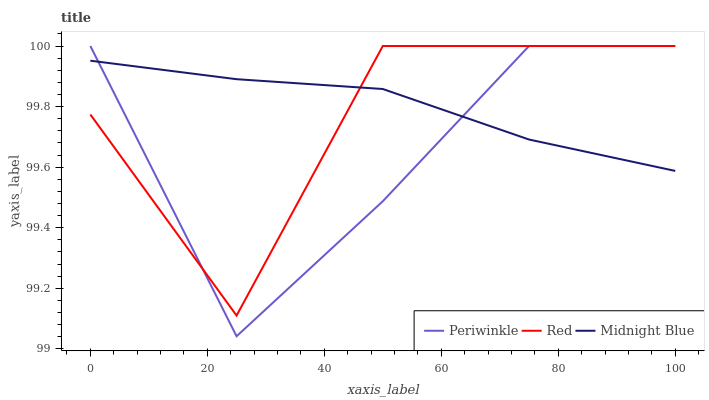Does Periwinkle have the minimum area under the curve?
Answer yes or no. Yes. Does Midnight Blue have the maximum area under the curve?
Answer yes or no. Yes. Does Red have the minimum area under the curve?
Answer yes or no. No. Does Red have the maximum area under the curve?
Answer yes or no. No. Is Midnight Blue the smoothest?
Answer yes or no. Yes. Is Red the roughest?
Answer yes or no. Yes. Is Red the smoothest?
Answer yes or no. No. Is Midnight Blue the roughest?
Answer yes or no. No. Does Periwinkle have the lowest value?
Answer yes or no. Yes. Does Red have the lowest value?
Answer yes or no. No. Does Red have the highest value?
Answer yes or no. Yes. Does Midnight Blue have the highest value?
Answer yes or no. No. Does Red intersect Periwinkle?
Answer yes or no. Yes. Is Red less than Periwinkle?
Answer yes or no. No. Is Red greater than Periwinkle?
Answer yes or no. No. 